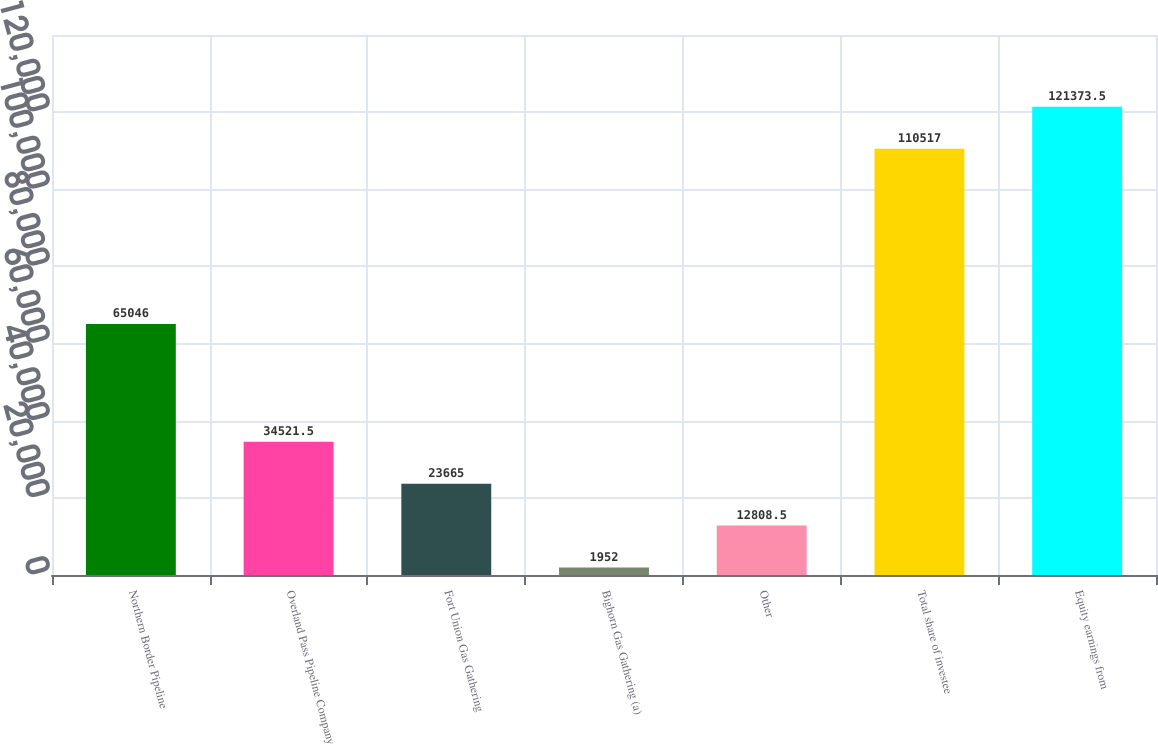<chart> <loc_0><loc_0><loc_500><loc_500><bar_chart><fcel>Northern Border Pipeline<fcel>Overland Pass Pipeline Company<fcel>Fort Union Gas Gathering<fcel>Bighorn Gas Gathering (a)<fcel>Other<fcel>Total share of investee<fcel>Equity earnings from<nl><fcel>65046<fcel>34521.5<fcel>23665<fcel>1952<fcel>12808.5<fcel>110517<fcel>121374<nl></chart> 